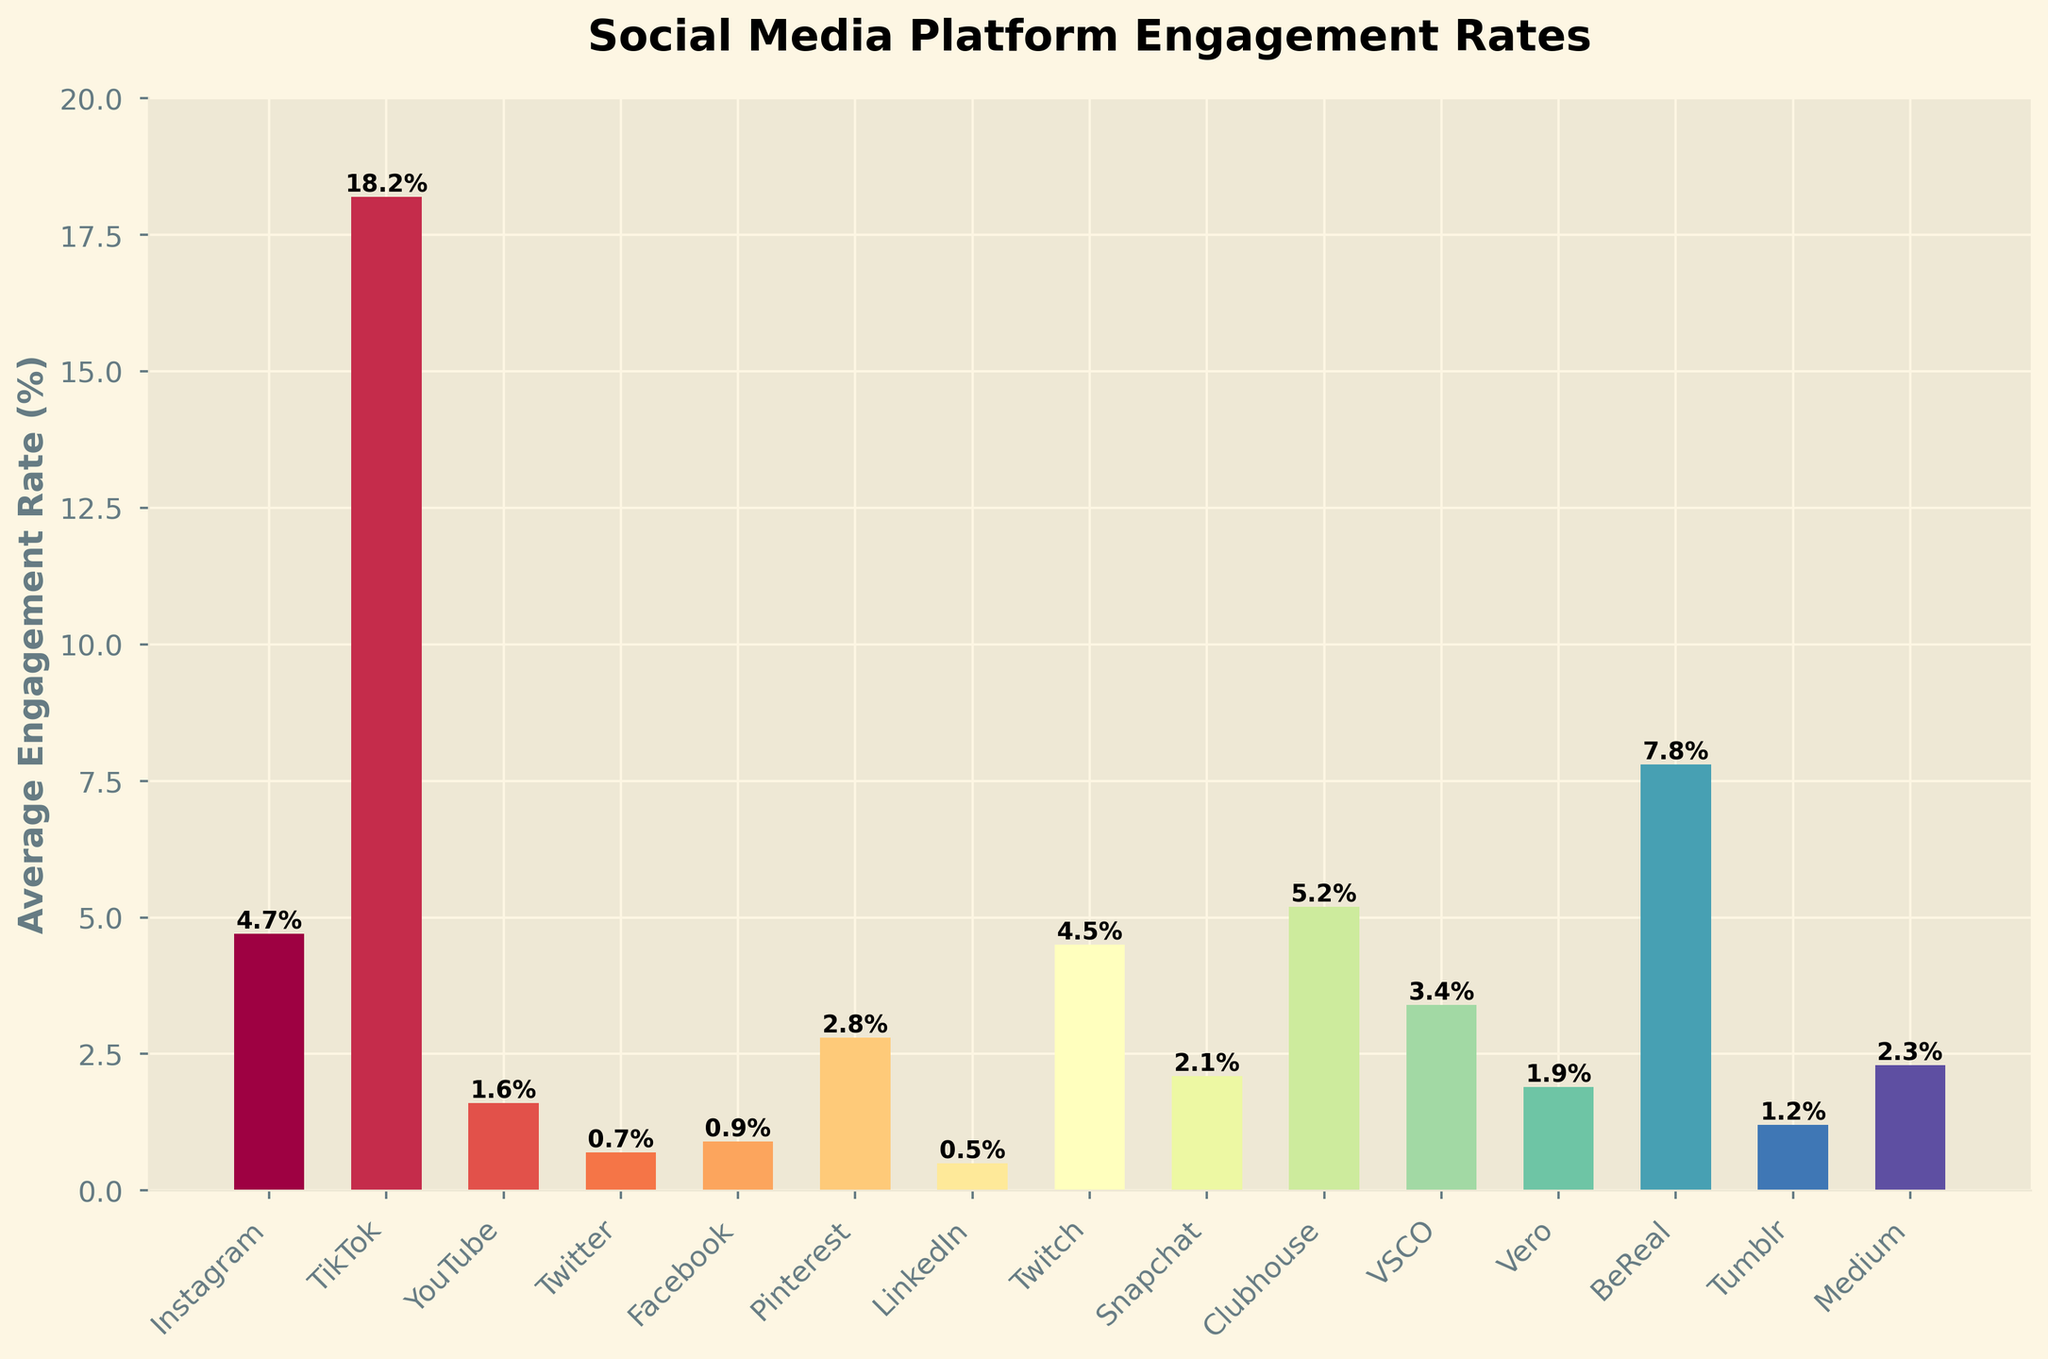Which social media platform has the highest average engagement rate? Look at the highest bar on the chart. The tallest bar represents TikTok, which has an average engagement rate of 18.2%.
Answer: TikTok Which platform has the lowest average engagement rate? Identify the shortest bar in the chart. The shortest bar represents LinkedIn, with an average engagement rate of 0.5%.
Answer: LinkedIn What is the difference in average engagement rate between TikTok and Instagram? Subtract the average engagement rate of Instagram (4.7%) from that of TikTok (18.2%). The result is 18.2% - 4.7% = 13.5%.
Answer: 13.5% How many platforms have an average engagement rate higher than 4%? Count the number of bars that reach above the 4% mark. The platforms are Instagram, TikTok, Clubhouse, BeReal, and Twitch. There are 5 such platforms.
Answer: 5 Which platform, Snapchat or Pinterest, has a higher average engagement rate? Look at the height of the bars corresponding to Snapchat and Pinterest. The bar for Pinterest is taller at 2.8%, compared to Snapchat's 2.1%.
Answer: Pinterest Is the average engagement rate of Tumblr more or less than half of that of Clubhouse? The average engagement rate of Tumblr is 1.2%, and half of Clubhouse's rate (5.2%) is 2.6%. Since 1.2% < 2.6%, the answer is less.
Answer: Less What's the combined average engagement rate of Facebook, Twitter, and LinkedIn? Add the average engagement rates of these platforms: Facebook (0.9%), Twitter (0.7%), and LinkedIn (0.5%). The combined rate is 0.9% + 0.7% + 0.5% = 2.1%.
Answer: 2.1% Which platform has a higher average engagement rate, BeReal or VSCO? Compare the heights of the bars for BeReal and VSCO. BeReal has an average engagement rate of 7.8%, and VSCO has 3.4%. BeReal's rate is higher.
Answer: BeReal Is the average engagement rate of YouTube more than double that of Medium? Calculate the double of Medium's rate which is 2.3% * 2 = 4.6%. YouTube's rate is 1.6%, so it is not more than double.
Answer: No 